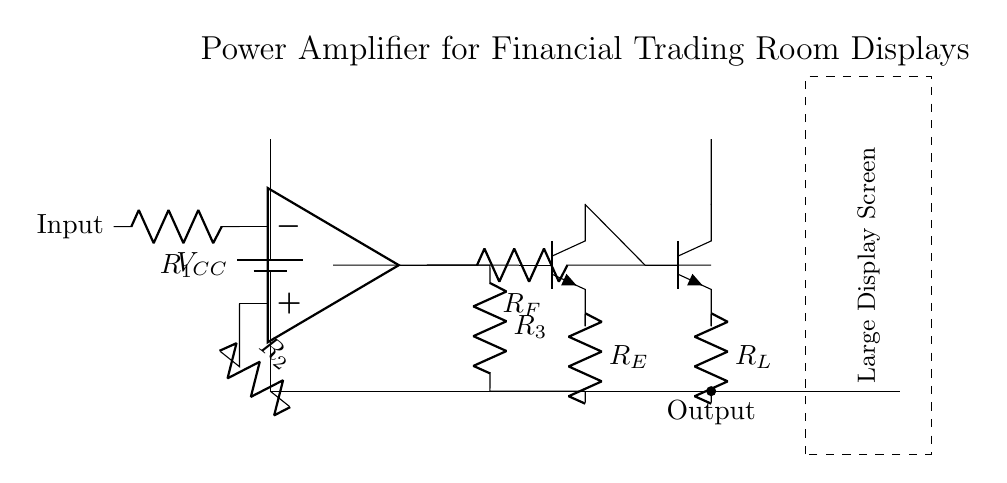What is the input resistance of the amplifier? The input resistance can be determined from the resistor R1 connected to the inverting input of the op-amp. In this circuit, R1 is the only component that connects to the input, indicating it sets the input resistance.
Answer: R1 What type of transistors are used in this amplifier? The circuit uses NPN transistors for the amplification stage, as indicated by the symbols shown in the diagram for both Q1 and Q2.
Answer: NPN What is the role of R_E in this circuit? Resistor R_E provides emitter stabilization for the transistor Q1, contributing to biasing and maintaining consistent performance despite variations in temperature or transistor parameters.
Answer: Stabilization How many stages does this amplifier have? This circuit features three main stages: the input stage (the operational amplifier), the amplification stage (where the transistors Q1 and Q2 are located), and the output stage (where the load is connected).
Answer: Three What component is used to provide feedback in this circuit? The feedback component is resistor R_F, which connects the output of transistor Q2 back to the inverting input of the operational amplifier. This connection is crucial for determining the amplifier's gain and stability.
Answer: R_F What is being powered by V_CC in the circuit? The voltage supply V_CC powers the entire amplifier circuit, including the transistors and operational amplifier, enabling the amplification process to drive the large display screen.
Answer: Entire circuit What is the purpose of R_L in this circuit? Resistor R_L signifies the load resistance connected to the output of transistor Q2 and represents the display screen in the circuit; it influences the overall load on the amplifier and its efficiency.
Answer: Load resistance 